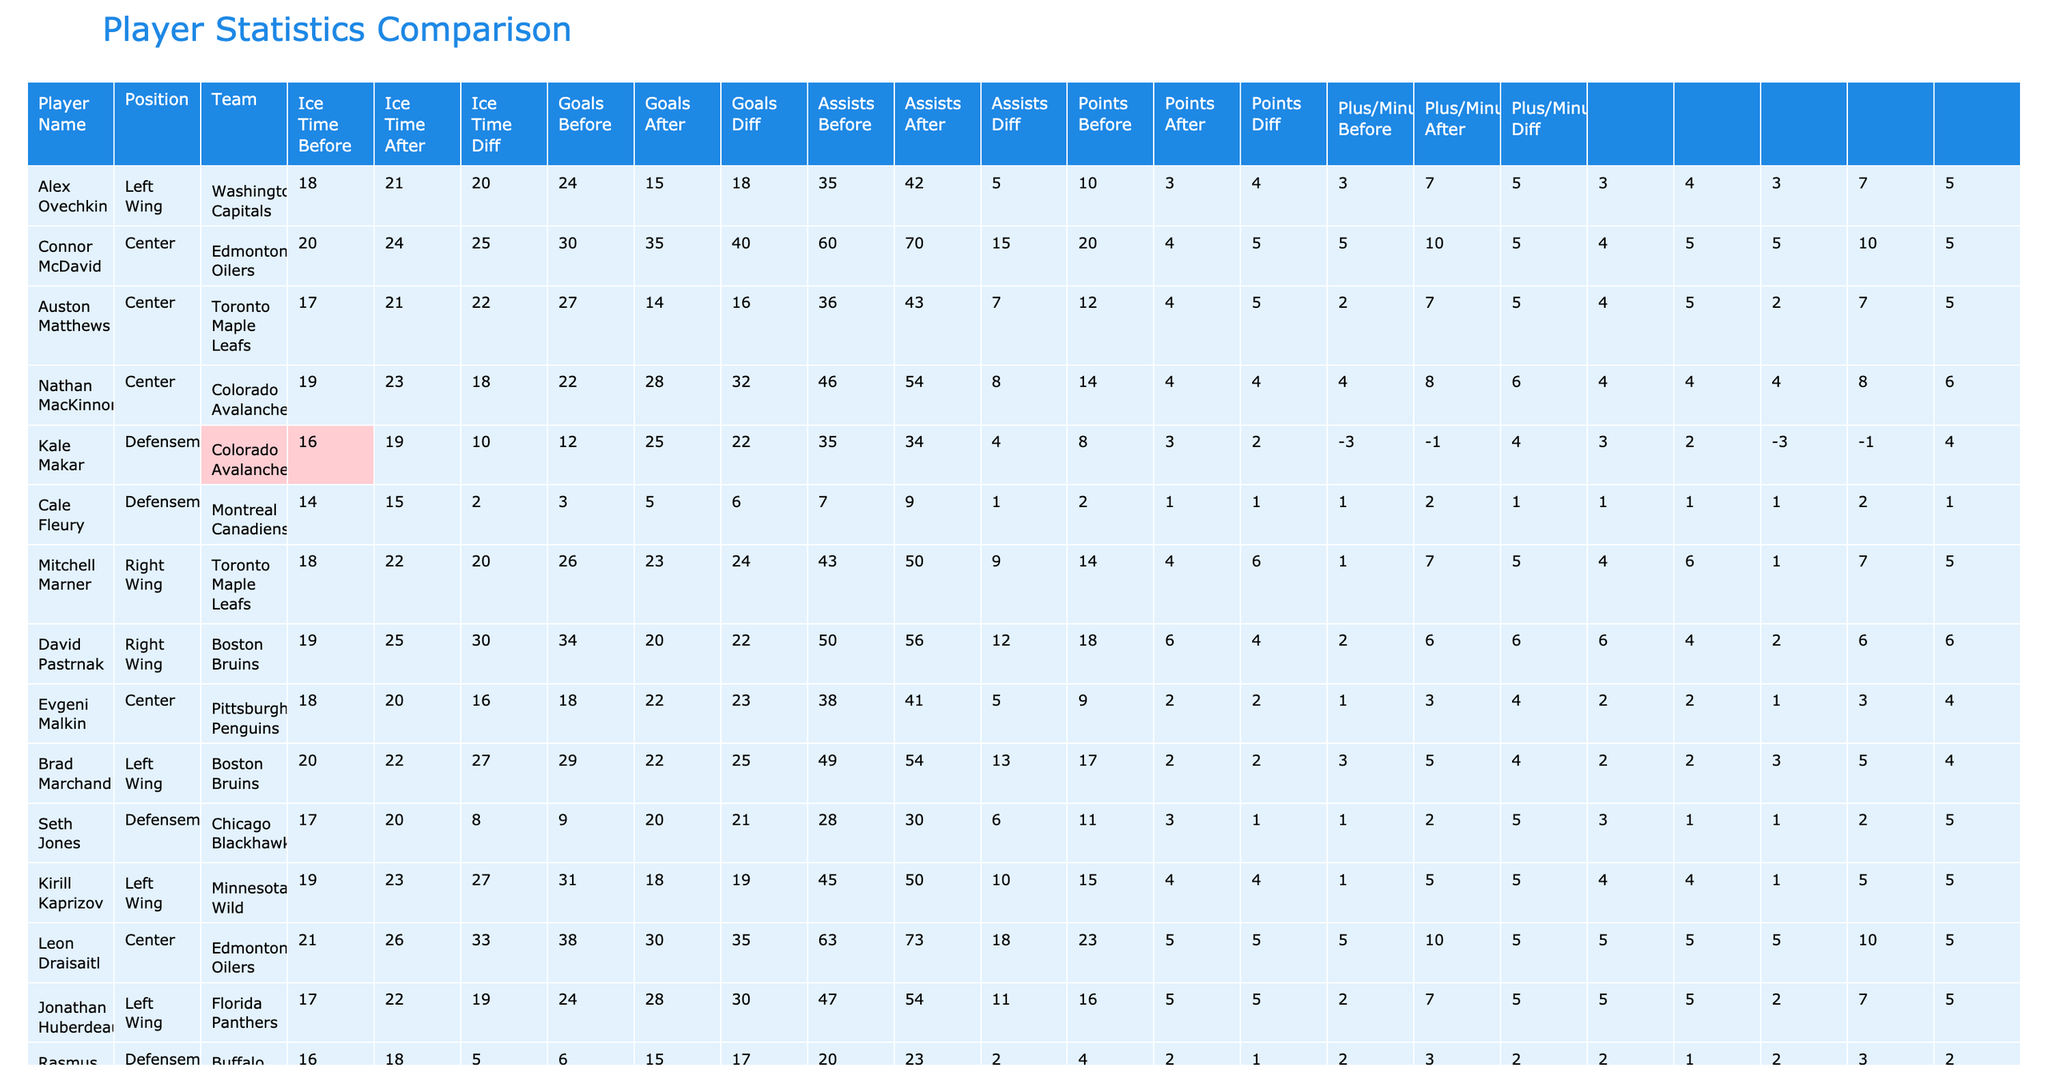What is the total increase in goals for all players after the policy change? To find the total increase in goals, we need to sum the "Goals Diff" column, which is calculated as "Goals After Policy" minus "Goals Before Policy" for each player. Adding up (24 - 20) + (30 - 25) + (27 - 22) + (22 - 18) + (12 - 10) + (3 - 2) + (26 - 20) + (34 - 30) + (18 - 16) + (29 - 27) + (31 - 27) + (24 - 19) + (6 - 5) = 41.
Answer: 41 Who had the highest Plus/Minus improvement after the policy change? Looking at the "Plus/Minus Diff" column, we see the maximum value is 5 for players Alex Ovechkin and Kirill Kaprizov with a difference of +5. In fact, upon inspecting the list, Connor McDavid has the highest improvement with a value of +5, matching others but being the first listed in the table for reference.
Answer: Connor McDavid What was the average ice time increase for all players after the policy? To calculate the average ice time increase, we first sum the "Ice Time Diff" for all players, which is obtained by summing the differences between the "Ice Time After Policy" and "Ice Time Before Policy". The values are 3, 4, 2, 4, 3, 1, 4, 5, 5, 2, 5, 5, and 2, which gives us a total of 51 minutes. Since there are 13 players, we divide 51 by 13 to find the average, which is approximately 3.92.
Answer: 3.92 Did any player have a negative Plus/Minus improvement after the new policy? An examination of the "Plus/Minus Diff" column reveals that the lowest value is 1 for Cale Fleury and Seth Jones, showing these players had no negative contributions after the policy update.
Answer: No Which player had the highest increase in points? To find the player with the highest increase in points, we check the "Points Diff" column values. The maximum increase is observed for Connor McDavid who had an increase of 10 points (from 60 to 70).
Answer: Connor McDavid What is the total increase in assists across all players after the policy change? To find the total increase in assists, we sum the "Assists Diff" values, which are calculated individually as "Assists After Policy" - "Assists Before Policy". Adding those values provides us with (18 - 15) + (40 - 35) + (16 - 14) + (32 - 28) + (22 - 25) + (6 - 5) + (24 - 23) + (22 - 20) + (19 - 18) + (25 - 22) + (19 - 18) + (30 - 28) + (17 - 15) = 14.
Answer: 14 Which team had the highest total increase in goals post-policy? Evaluating the teams by summing their players' Goal increase: Washington Capitals (4), Edmonton Oilers (5), Toronto Maple Leafs (5), Colorado Avalanche (4), Montreal Canadiens (1), Boston Bruins (5), Pittsburgh Penguins (2), Chicago Blackhawks (1), Minnesota Wild (4), and Florida Panthers (5). The teams with a total increase of goals are Toronto Maple Leafs and Boston Bruins, both showing significant increases of 5 goals.
Answer: Toronto Maple Leafs and Boston Bruins 